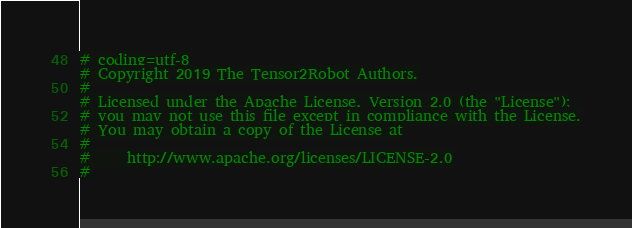<code> <loc_0><loc_0><loc_500><loc_500><_Python_># coding=utf-8
# Copyright 2019 The Tensor2Robot Authors.
#
# Licensed under the Apache License, Version 2.0 (the "License");
# you may not use this file except in compliance with the License.
# You may obtain a copy of the License at
#
#     http://www.apache.org/licenses/LICENSE-2.0
#</code> 